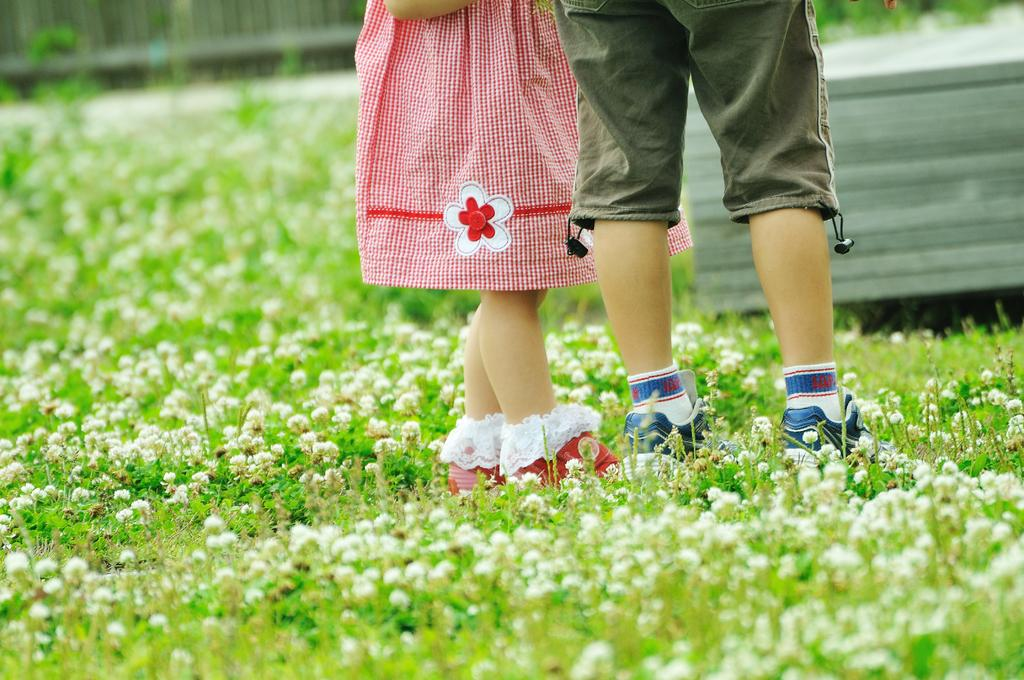How many people are in the image? There are two persons in the image. What is the ground like where the persons are standing? The ground is a greenery area. What can be seen in the background of the image? There is a fence wall in the background of the image. How far away is the airplane from the persons in the image? There is no airplane present in the image, so it is not possible to determine the distance between the persons and an airplane. 